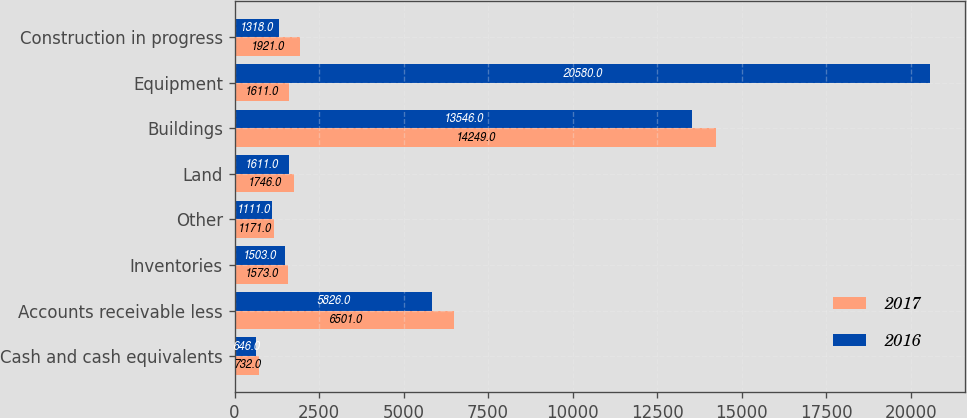Convert chart to OTSL. <chart><loc_0><loc_0><loc_500><loc_500><stacked_bar_chart><ecel><fcel>Cash and cash equivalents<fcel>Accounts receivable less<fcel>Inventories<fcel>Other<fcel>Land<fcel>Buildings<fcel>Equipment<fcel>Construction in progress<nl><fcel>2017<fcel>732<fcel>6501<fcel>1573<fcel>1171<fcel>1746<fcel>14249<fcel>1611<fcel>1921<nl><fcel>2016<fcel>646<fcel>5826<fcel>1503<fcel>1111<fcel>1611<fcel>13546<fcel>20580<fcel>1318<nl></chart> 